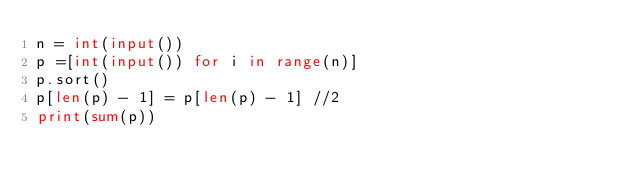Convert code to text. <code><loc_0><loc_0><loc_500><loc_500><_Python_>n = int(input())
p =[int(input()) for i in range(n)]
p.sort()
p[len(p) - 1] = p[len(p) - 1] //2
print(sum(p))</code> 